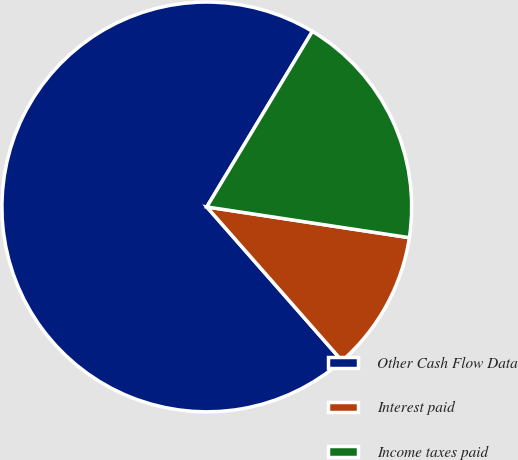Convert chart to OTSL. <chart><loc_0><loc_0><loc_500><loc_500><pie_chart><fcel>Other Cash Flow Data<fcel>Interest paid<fcel>Income taxes paid<nl><fcel>70.09%<fcel>11.13%<fcel>18.78%<nl></chart> 